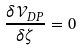Convert formula to latex. <formula><loc_0><loc_0><loc_500><loc_500>\frac { \delta \mathcal { V } _ { D P } } { \delta \zeta } = 0</formula> 